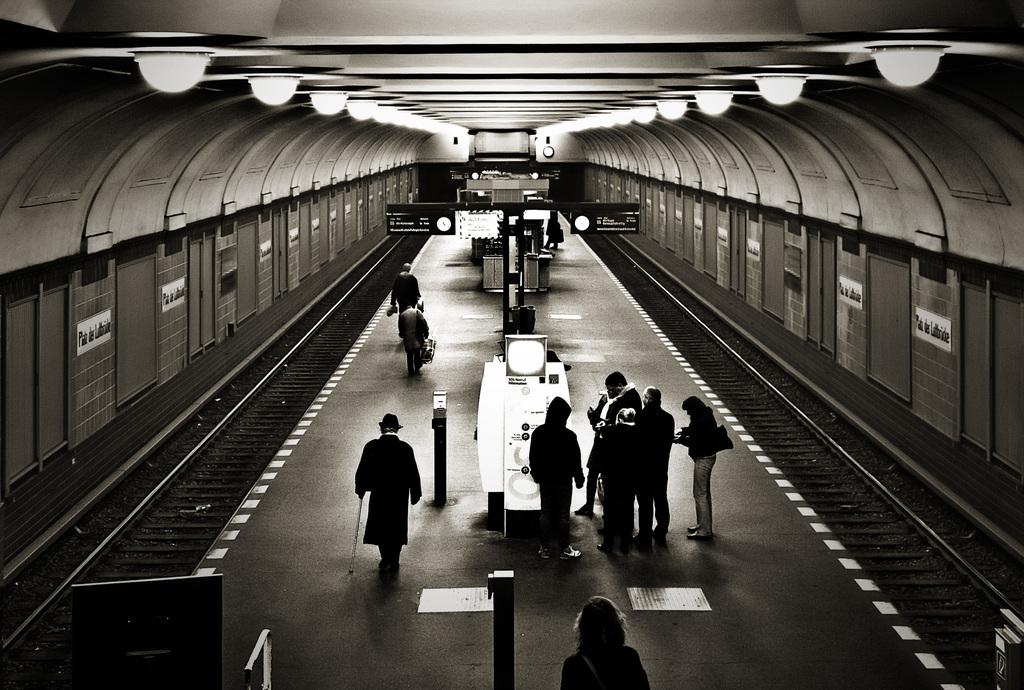What can be seen in the image? There are people, poles, a board, a machine, tracks, and a shed in the image. What is the purpose of the poles in the image? The purpose of the poles is not explicitly stated, but they may be used for support or as part of the structure. What is the machine in the image used for? The specific function of the machine is not mentioned, but it could be related to the tracks or the overall setting. What is visible in the background of the image? There are boards, a clock, and other objects visible in the background of the image. What can be seen at the top of the image? There are lights visible at the top of the image. Can you see a shop near the ocean in the image? There is no shop or ocean present in the image. Is there a locket hanging from the board in the image? There is no locket visible in the image. 